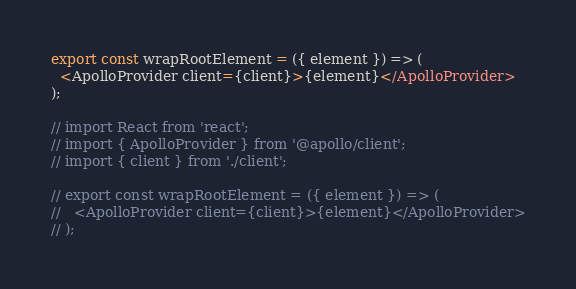Convert code to text. <code><loc_0><loc_0><loc_500><loc_500><_TypeScript_>
export const wrapRootElement = ({ element }) => (
  <ApolloProvider client={client}>{element}</ApolloProvider>
);

// import React from 'react';
// import { ApolloProvider } from '@apollo/client';
// import { client } from './client';

// export const wrapRootElement = ({ element }) => (
//   <ApolloProvider client={client}>{element}</ApolloProvider>
// );</code> 